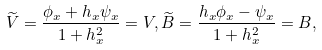<formula> <loc_0><loc_0><loc_500><loc_500>\widetilde { V } = \frac { \phi _ { x } + h _ { x } \psi _ { x } } { 1 + h _ { x } ^ { 2 } } = V , \widetilde { B } = \frac { h _ { x } \phi _ { x } - \psi _ { x } } { 1 + h _ { x } ^ { 2 } } = B ,</formula> 